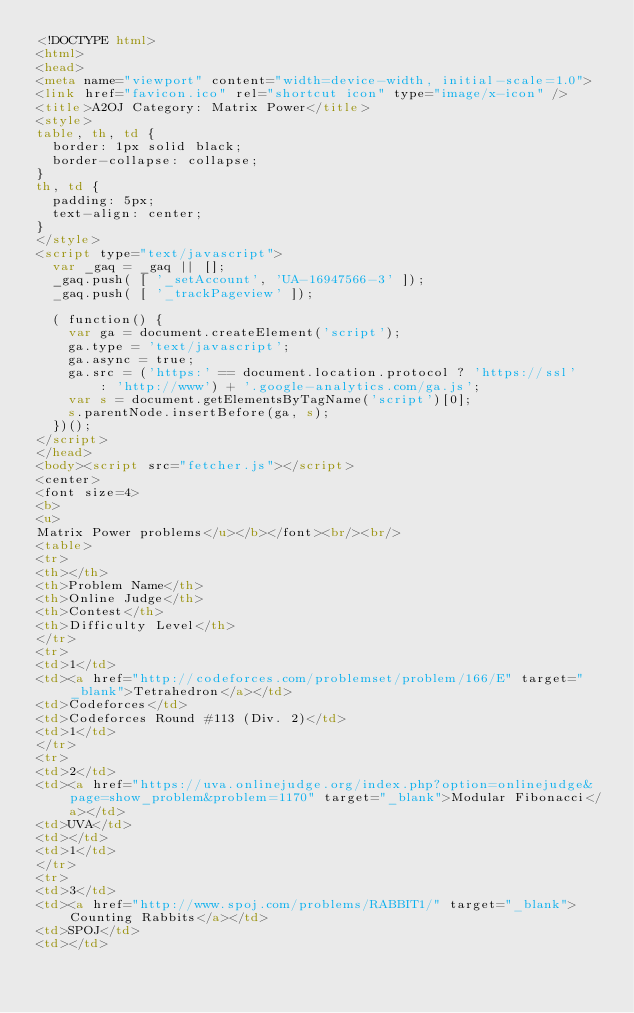<code> <loc_0><loc_0><loc_500><loc_500><_HTML_><!DOCTYPE html>
<html>
<head>
<meta name="viewport" content="width=device-width, initial-scale=1.0">
<link href="favicon.ico" rel="shortcut icon" type="image/x-icon" />
<title>A2OJ Category: Matrix Power</title>
<style>
table, th, td {
  border: 1px solid black;
  border-collapse: collapse;
}
th, td {
  padding: 5px;
  text-align: center;
}
</style>
<script type="text/javascript">
	var _gaq = _gaq || [];
	_gaq.push( [ '_setAccount', 'UA-16947566-3' ]);
	_gaq.push( [ '_trackPageview' ]);

	( function() {
		var ga = document.createElement('script');
		ga.type = 'text/javascript';
		ga.async = true;
		ga.src = ('https:' == document.location.protocol ? 'https://ssl'
				: 'http://www') + '.google-analytics.com/ga.js';
		var s = document.getElementsByTagName('script')[0];
		s.parentNode.insertBefore(ga, s);
	})();
</script>
</head>
<body><script src="fetcher.js"></script>
<center>
<font size=4>
<b>
<u>
Matrix Power problems</u></b></font><br/><br/>
<table>
<tr>
<th></th>
<th>Problem Name</th>
<th>Online Judge</th>
<th>Contest</th>
<th>Difficulty Level</th>
</tr>
<tr>
<td>1</td>
<td><a href="http://codeforces.com/problemset/problem/166/E" target="_blank">Tetrahedron</a></td>
<td>Codeforces</td>
<td>Codeforces Round #113 (Div. 2)</td>
<td>1</td>
</tr>
<tr>
<td>2</td>
<td><a href="https://uva.onlinejudge.org/index.php?option=onlinejudge&page=show_problem&problem=1170" target="_blank">Modular Fibonacci</a></td>
<td>UVA</td>
<td></td>
<td>1</td>
</tr>
<tr>
<td>3</td>
<td><a href="http://www.spoj.com/problems/RABBIT1/" target="_blank">Counting Rabbits</a></td>
<td>SPOJ</td>
<td></td></code> 